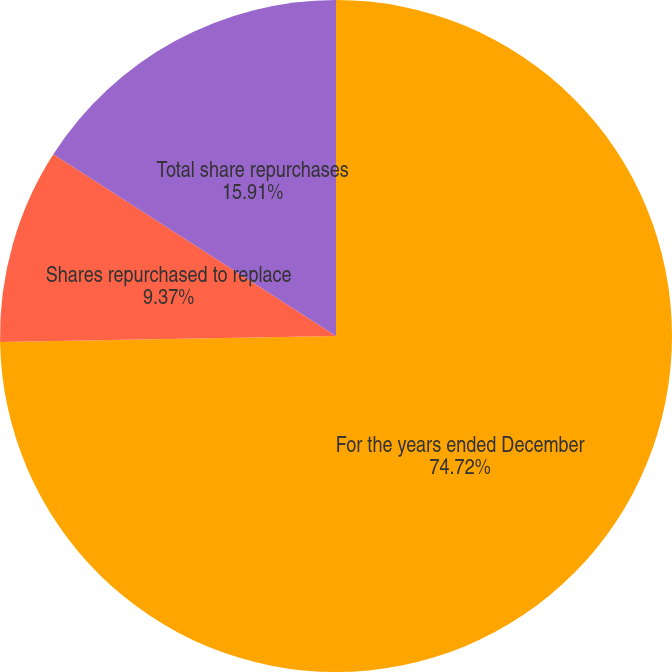Convert chart to OTSL. <chart><loc_0><loc_0><loc_500><loc_500><pie_chart><fcel>For the years ended December<fcel>Shares repurchased to replace<fcel>Total share repurchases<nl><fcel>74.72%<fcel>9.37%<fcel>15.91%<nl></chart> 